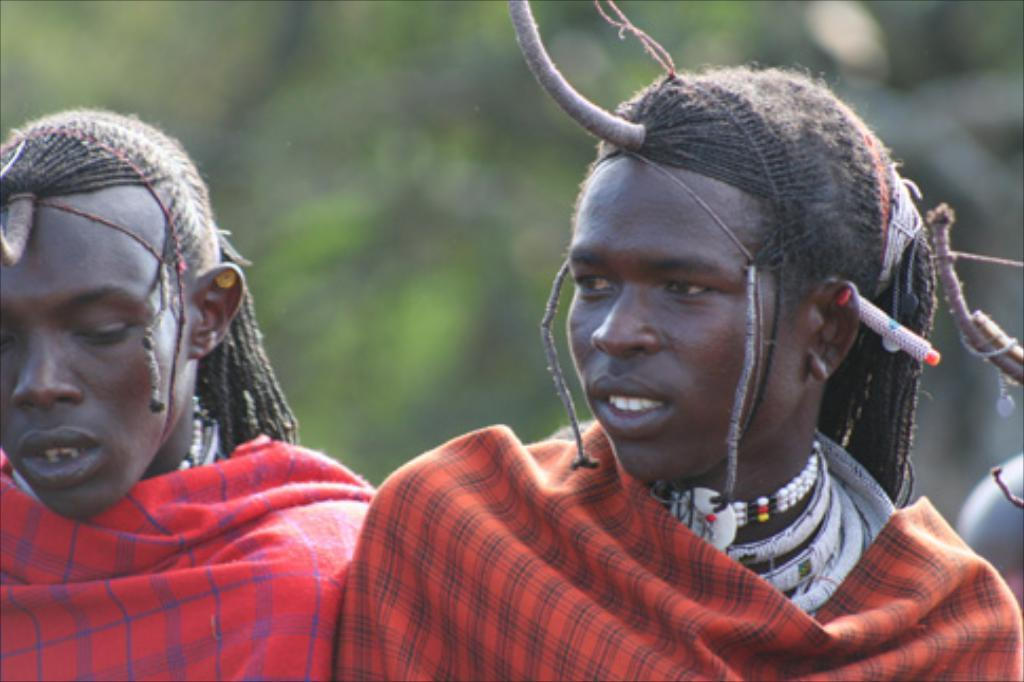What is the main subject of the image? The main subject of the image is the persons in the center. What can be seen in the background of the image? There are trees in the background of the image. What type of feather can be seen on the person's hat in the image? There is no feather visible on any person's hat in the image. How does the sense of smell play a role in the image? The sense of smell is not mentioned or depicted in the image, so it cannot be determined how it plays a role. 